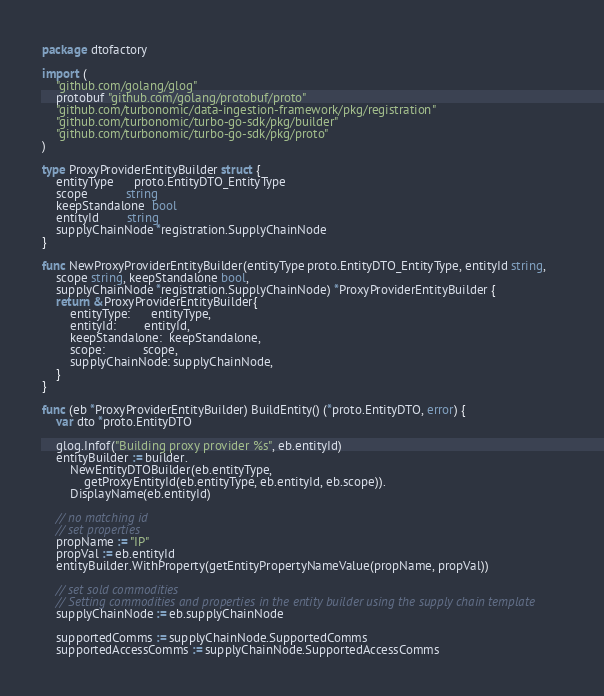<code> <loc_0><loc_0><loc_500><loc_500><_Go_>package dtofactory

import (
	"github.com/golang/glog"
	protobuf "github.com/golang/protobuf/proto"
	"github.com/turbonomic/data-ingestion-framework/pkg/registration"
	"github.com/turbonomic/turbo-go-sdk/pkg/builder"
	"github.com/turbonomic/turbo-go-sdk/pkg/proto"
)

type ProxyProviderEntityBuilder struct {
	entityType      proto.EntityDTO_EntityType
	scope           string
	keepStandalone  bool
	entityId        string
	supplyChainNode *registration.SupplyChainNode
}

func NewProxyProviderEntityBuilder(entityType proto.EntityDTO_EntityType, entityId string,
	scope string, keepStandalone bool,
	supplyChainNode *registration.SupplyChainNode) *ProxyProviderEntityBuilder {
	return &ProxyProviderEntityBuilder{
		entityType:      entityType,
		entityId:        entityId,
		keepStandalone:  keepStandalone,
		scope:           scope,
		supplyChainNode: supplyChainNode,
	}
}

func (eb *ProxyProviderEntityBuilder) BuildEntity() (*proto.EntityDTO, error) {
	var dto *proto.EntityDTO

	glog.Infof("Building proxy provider %s", eb.entityId)
	entityBuilder := builder.
		NewEntityDTOBuilder(eb.entityType,
			getProxyEntityId(eb.entityType, eb.entityId, eb.scope)).
		DisplayName(eb.entityId)

	// no matching id
	// set properties
	propName := "IP"
	propVal := eb.entityId
	entityBuilder.WithProperty(getEntityPropertyNameValue(propName, propVal))

	// set sold commodities
	// Setting commodities and properties in the entity builder using the supply chain template
	supplyChainNode := eb.supplyChainNode

	supportedComms := supplyChainNode.SupportedComms
	supportedAccessComms := supplyChainNode.SupportedAccessComms
</code> 